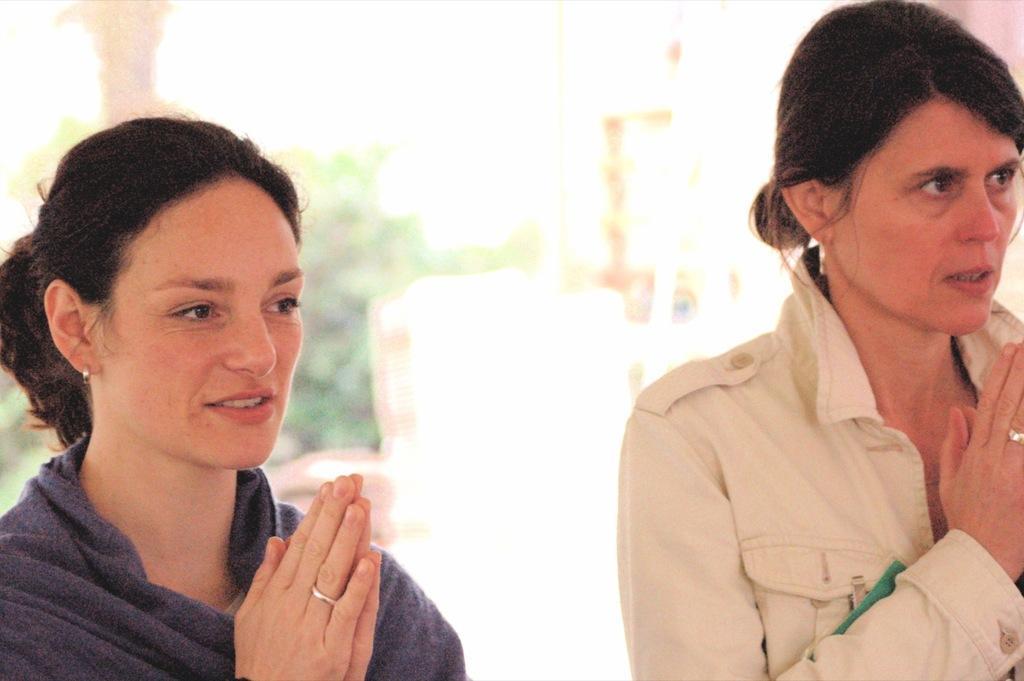How would you summarize this image in a sentence or two? In this image there are two women standing and the background is blurred. 